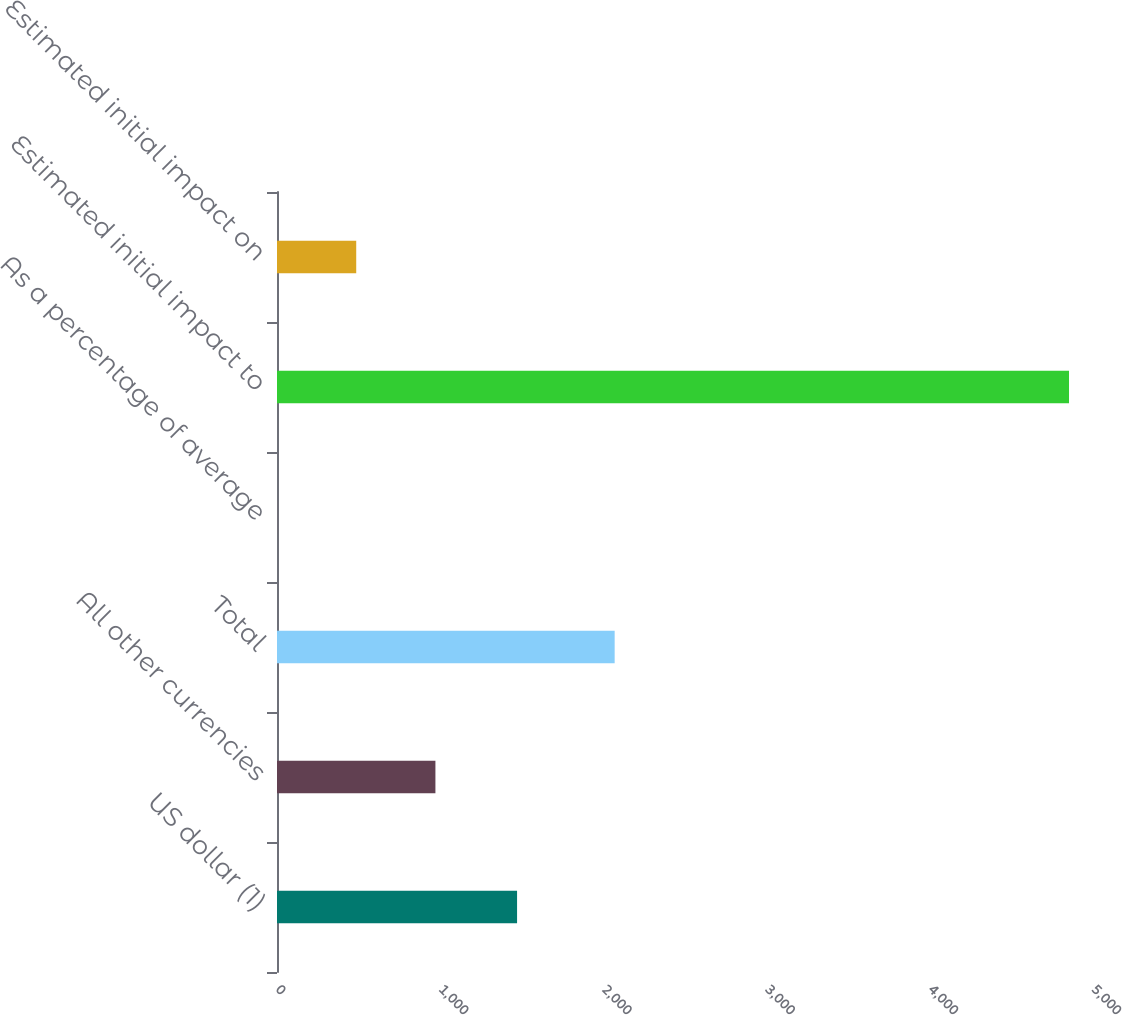Convert chart. <chart><loc_0><loc_0><loc_500><loc_500><bar_chart><fcel>US dollar (1)<fcel>All other currencies<fcel>Total<fcel>As a percentage of average<fcel>Estimated initial impact to<fcel>Estimated initial impact on<nl><fcel>1471<fcel>970.7<fcel>2069<fcel>0.12<fcel>4853<fcel>485.41<nl></chart> 